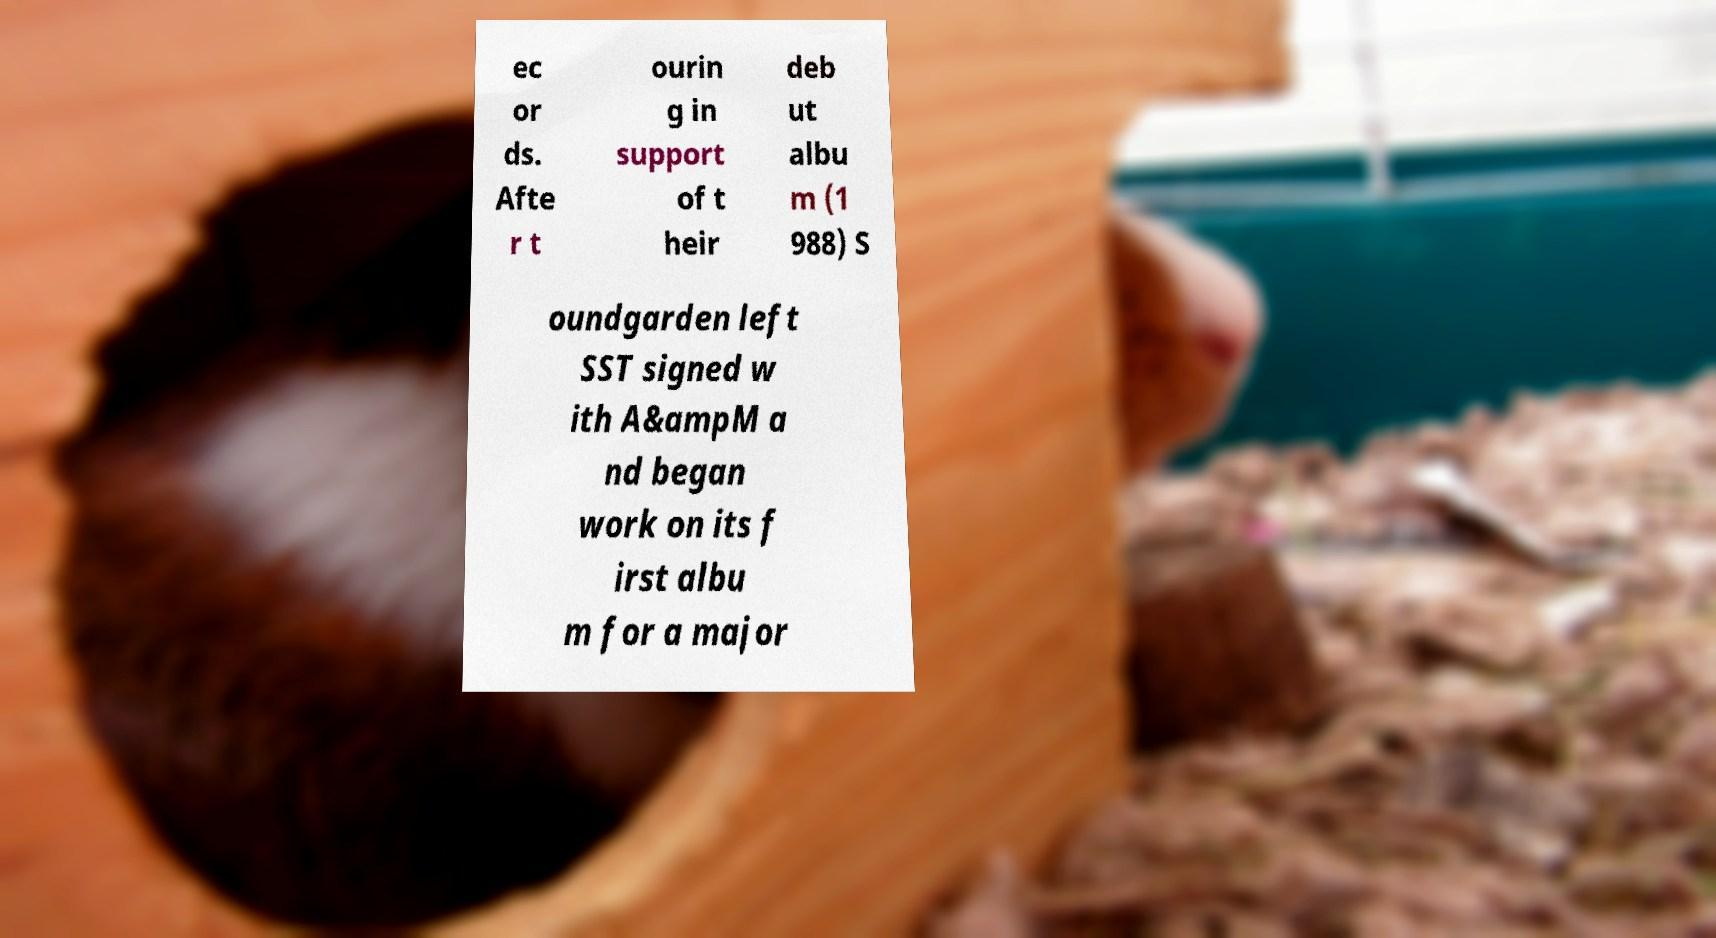For documentation purposes, I need the text within this image transcribed. Could you provide that? ec or ds. Afte r t ourin g in support of t heir deb ut albu m (1 988) S oundgarden left SST signed w ith A&ampM a nd began work on its f irst albu m for a major 